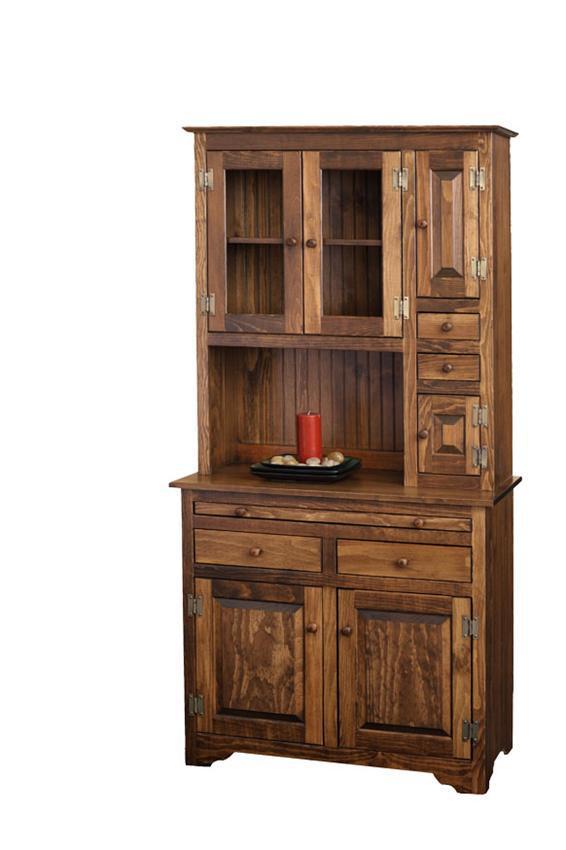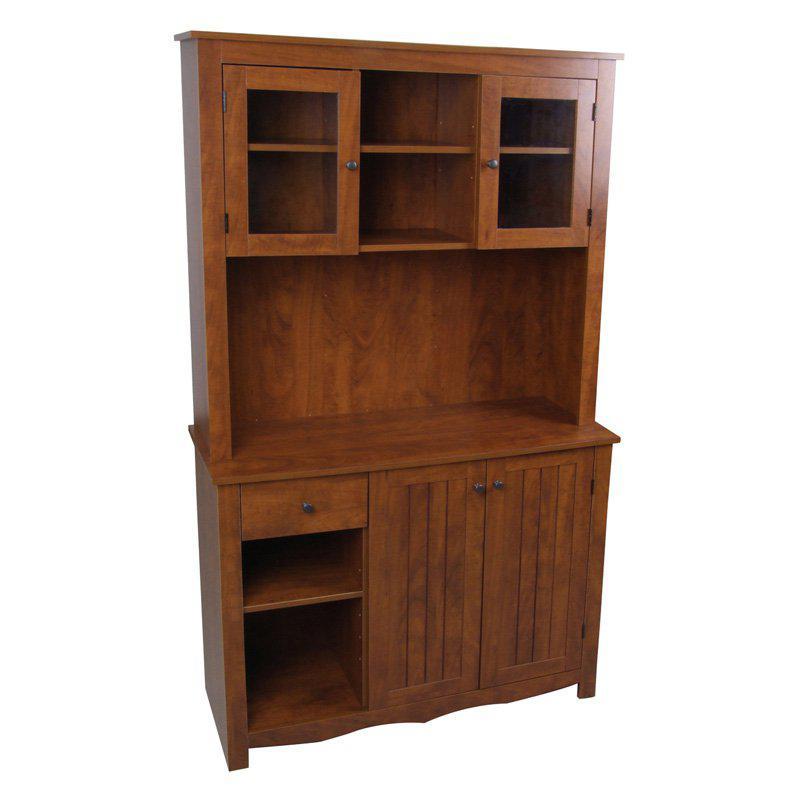The first image is the image on the left, the second image is the image on the right. For the images shown, is this caption "One of these images contains a completely empty hutch, and all of these images are on a plain white background." true? Answer yes or no. Yes. The first image is the image on the left, the second image is the image on the right. For the images shown, is this caption "Brown cabinets are on a stark white background" true? Answer yes or no. Yes. 